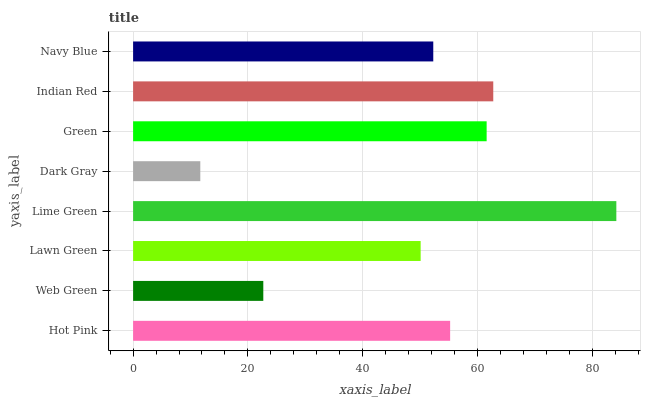Is Dark Gray the minimum?
Answer yes or no. Yes. Is Lime Green the maximum?
Answer yes or no. Yes. Is Web Green the minimum?
Answer yes or no. No. Is Web Green the maximum?
Answer yes or no. No. Is Hot Pink greater than Web Green?
Answer yes or no. Yes. Is Web Green less than Hot Pink?
Answer yes or no. Yes. Is Web Green greater than Hot Pink?
Answer yes or no. No. Is Hot Pink less than Web Green?
Answer yes or no. No. Is Hot Pink the high median?
Answer yes or no. Yes. Is Navy Blue the low median?
Answer yes or no. Yes. Is Dark Gray the high median?
Answer yes or no. No. Is Hot Pink the low median?
Answer yes or no. No. 